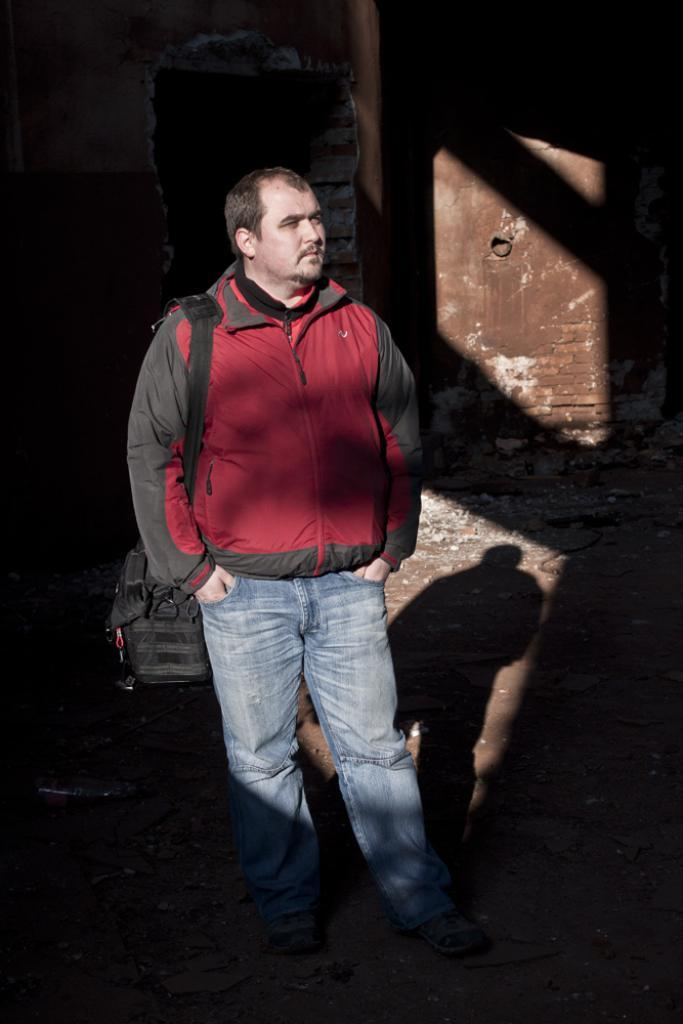What is the main subject of the image? There is a man in the image. What is the man doing in the image? The man is standing in the image. What is the man holding or carrying in the image? The man is carrying a bag in the image. What can be seen in the background of the image? There is a wall in the background of the image. Is there any additional detail visible in the image? Yes, there is a shadow visible in the image. Are there any cobwebs visible in the image? No, there are no cobwebs visible in the image. How many brothers does the man in the image have? The provided facts do not mention any brothers, so we cannot determine the number of brothers the man has from the image. 